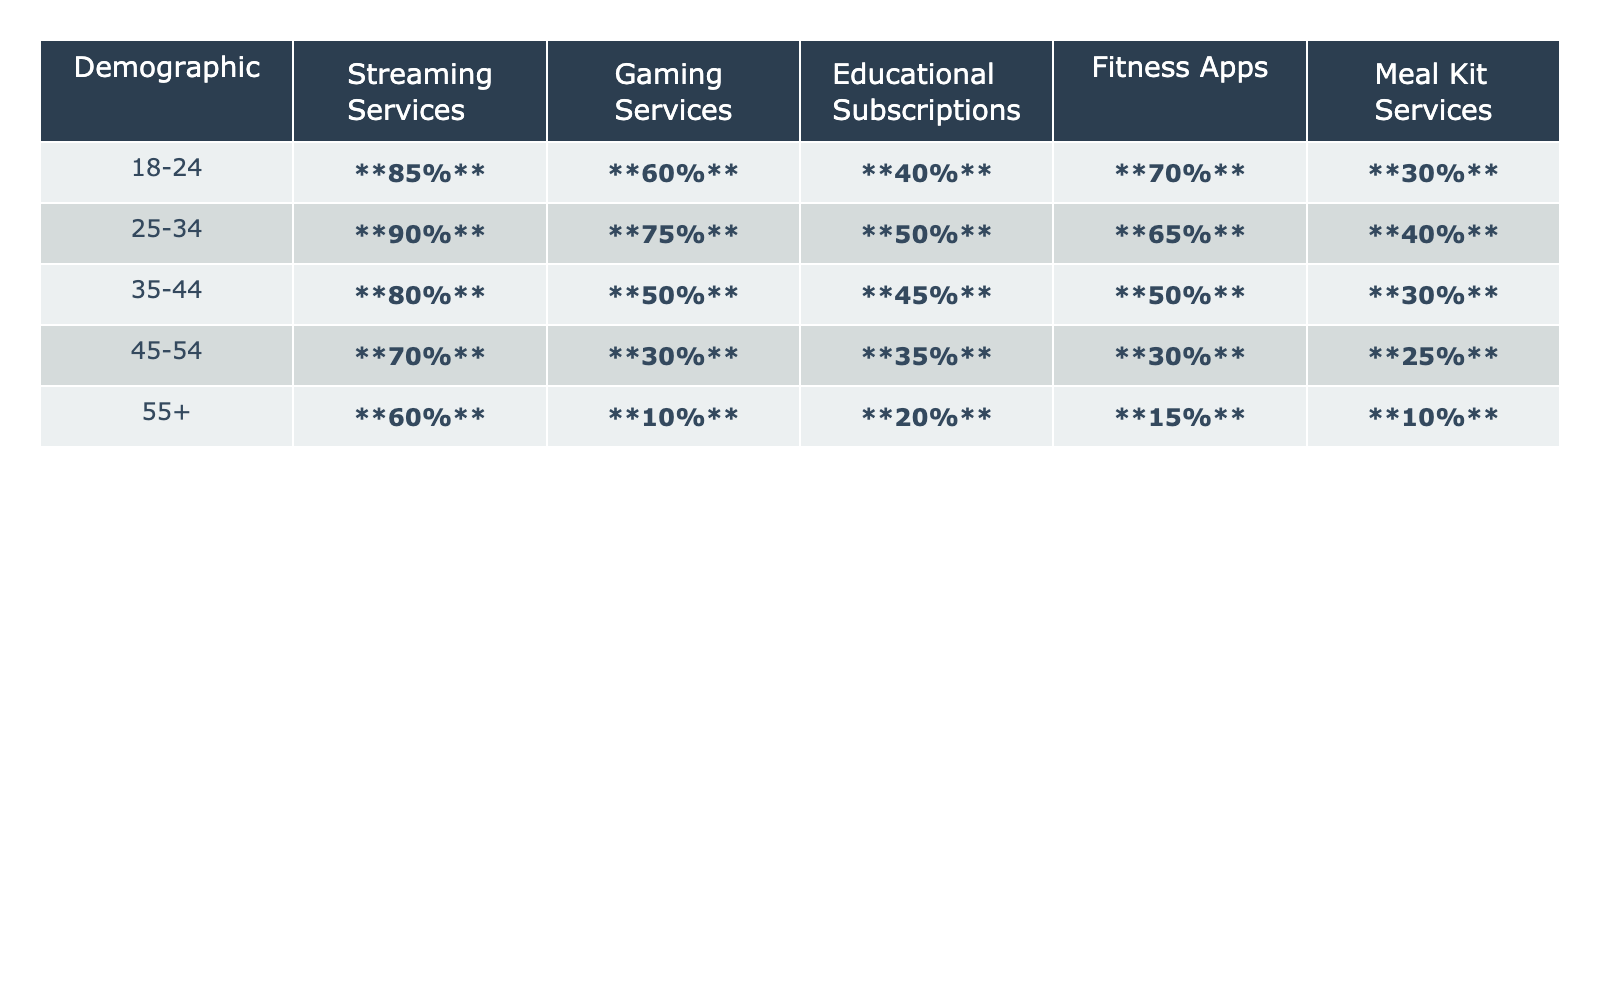What percentage of the 35-44 demographic uses Gaming Services? According to the table, the percentage usage of Gaming Services for the 35-44 demographic is listed as 50%.
Answer: 50% Which demographic has the highest percentage usage of Fitness Apps? The table shows that the 18-24 demographic has a percentage usage of 70%, which is the highest for Fitness Apps.
Answer: 70% Is the percentage usage of Educational Subscriptions higher for the 25-34 demographic than the 45-54 demographic? The table indicates that the 25-34 demographic uses Educational Subscriptions at 50%, while the 45-54 demographic uses them at 35%. Therefore, yes, 50% is greater than 35%.
Answer: Yes What is the total percentage usage for Meal Kit Services across all demographics? Adding the percentages for Meal Kit Services across all demographics: 30% + 40% + 30% + 25% + 10% equals 145%.
Answer: 145% Which service type has the highest percentage usage among individuals aged 55 and older? In the table, Streaming Services has a usage of 60%, which is higher than the other services for the 55+ demographic: Gaming Services (10%), Educational Subscriptions (20%), Fitness Apps (15%), and Meal Kit Services (10%).
Answer: Streaming Services What is the average percentage usage of Gaming Services for the demographics listed? To find the average for Gaming Services: (60% + 75% + 50% + 30% + 10%) = 225%. There are 5 data points, so the average is 225% / 5 = 45%.
Answer: 45% Are there any demographics where less than 20% of individuals use Meal Kit Services? The table reveals that the 55+ demographic has only 10% usage of Meal Kit Services, which is less than 20%.
Answer: Yes What is the difference in percentage usage of Streaming Services between the 25-34 and the 55+ demographic? The percentage usage for the 25-34 demographic is 90% and for the 55+ demographic it is 60%. The difference is 90% - 60% = 30%.
Answer: 30% Which demographic has the least percentage usage of Fitness Apps? Examining the table shows that the 55+ demographic has the lowest percentage usage of Fitness Apps at 15%.
Answer: 15% How does the percentage usage of Educational Subscriptions change from the 18-24 to the 45-54 demographic? The 18-24 demographic has a usage of 40% for Educational Subscriptions, while the 45-54 demographic has 35%. This shows a decrease of 5%.
Answer: Decrease of 5% 